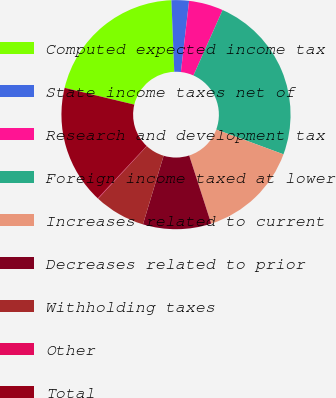Convert chart. <chart><loc_0><loc_0><loc_500><loc_500><pie_chart><fcel>Computed expected income tax<fcel>State income taxes net of<fcel>Research and development tax<fcel>Foreign income taxed at lower<fcel>Increases related to current<fcel>Decreases related to prior<fcel>Withholding taxes<fcel>Other<fcel>Total<nl><fcel>20.6%<fcel>2.46%<fcel>4.85%<fcel>23.95%<fcel>14.4%<fcel>9.63%<fcel>7.24%<fcel>0.07%<fcel>16.79%<nl></chart> 